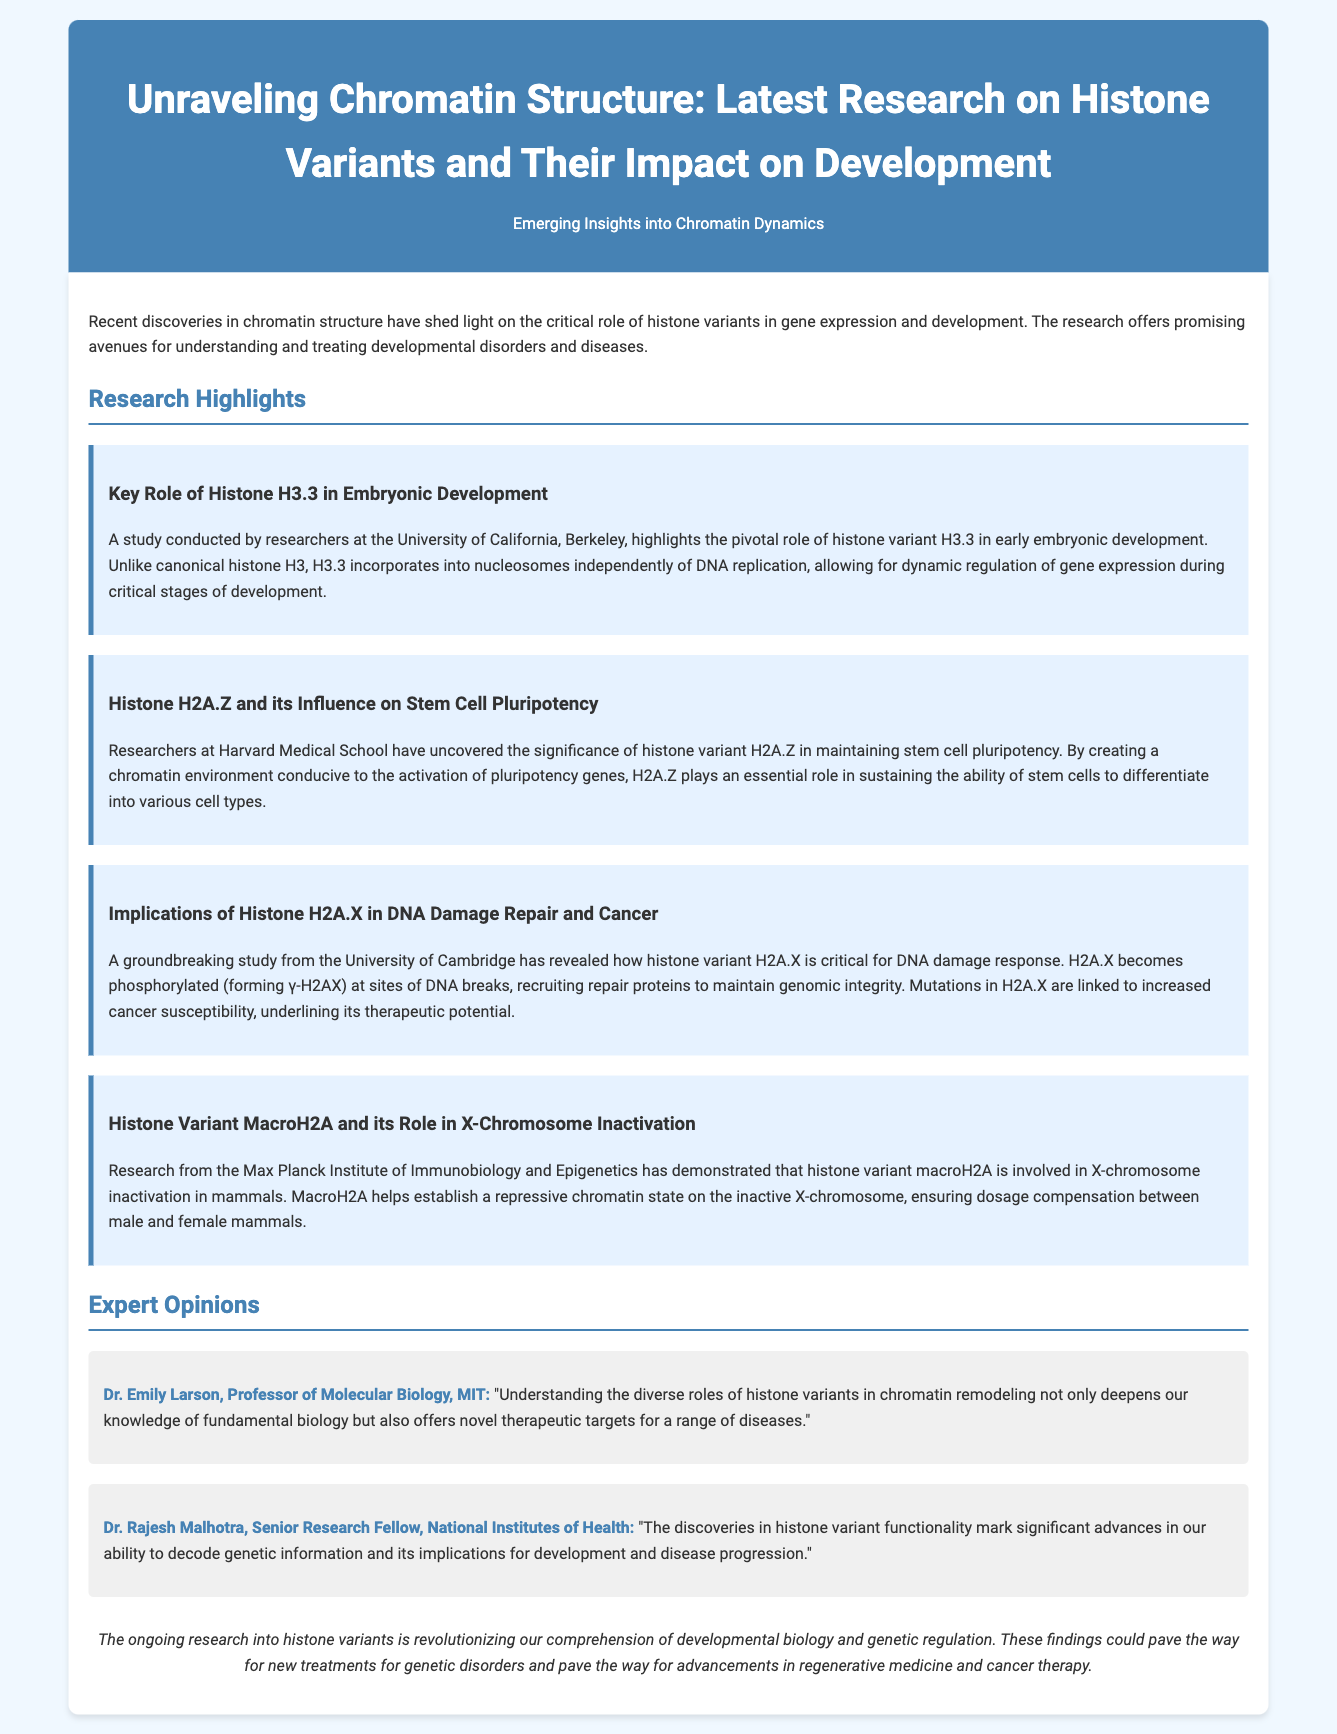What is the title of the press release? The title of the press release is stated at the beginning of the document.
Answer: Unraveling Chromatin Structure: Latest Research on Histone Variants and Their Impact on Development Which histone variant is highlighted in the role of embryonic development? The document specifically mentions the histone variant that plays a critical role in embryonic development.
Answer: H3.3 What does H2A.Z influence in stem cells? The document explains the significance of H2A.Z in relation to stem cells.
Answer: Pluripotency What is the role of H2A.X in DNA damage repair? The document describes the function of H2A.X in the context of DNA damage response.
Answer: Critical Which institution conducted the research on macroH2A? The document names the institution responsible for studying macroH2A.
Answer: Max Planck Institute of Immunobiology and Epigenetics Who is Dr. Emily Larson? The document introduces an expert providing opinion on the research findings.
Answer: Professor of Molecular Biology, MIT What does the ongoing research aim to revolutionize? The document concludes with the broader impact of research into histone variants.
Answer: Developmental biology How does the document categorize its content? The structure of the document includes specific sections dedicated to different content areas.
Answer: Expert Opinions 